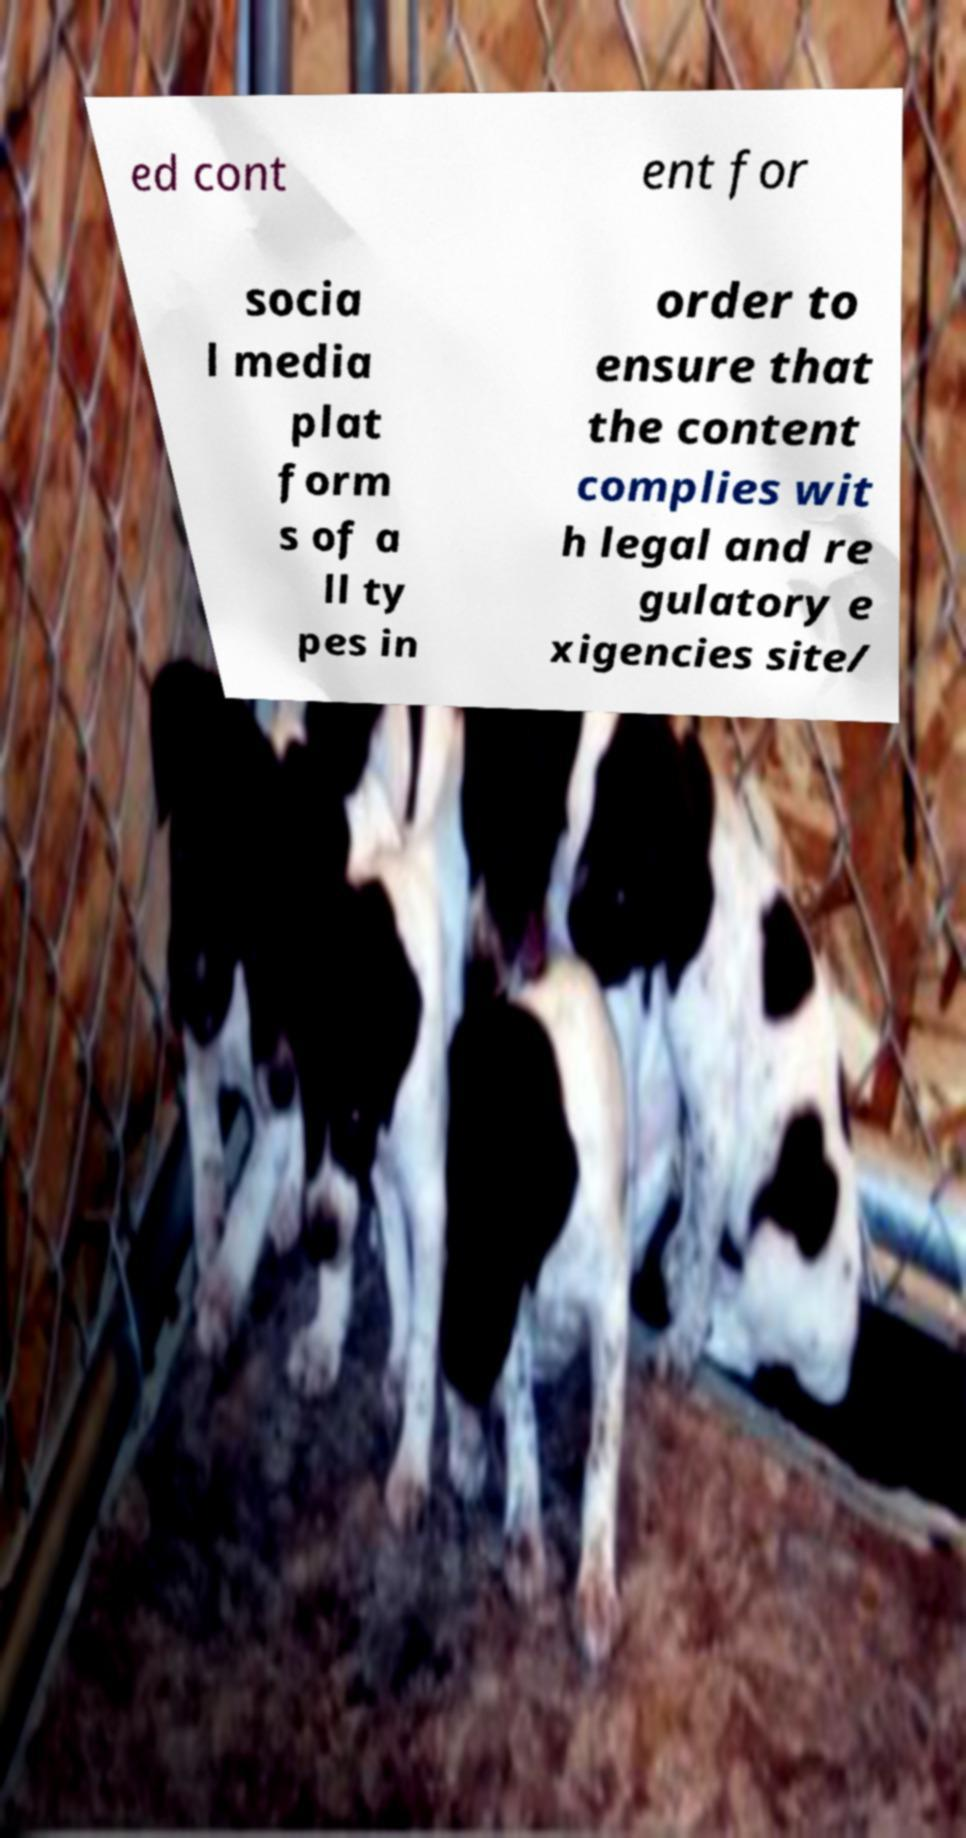I need the written content from this picture converted into text. Can you do that? ed cont ent for socia l media plat form s of a ll ty pes in order to ensure that the content complies wit h legal and re gulatory e xigencies site/ 